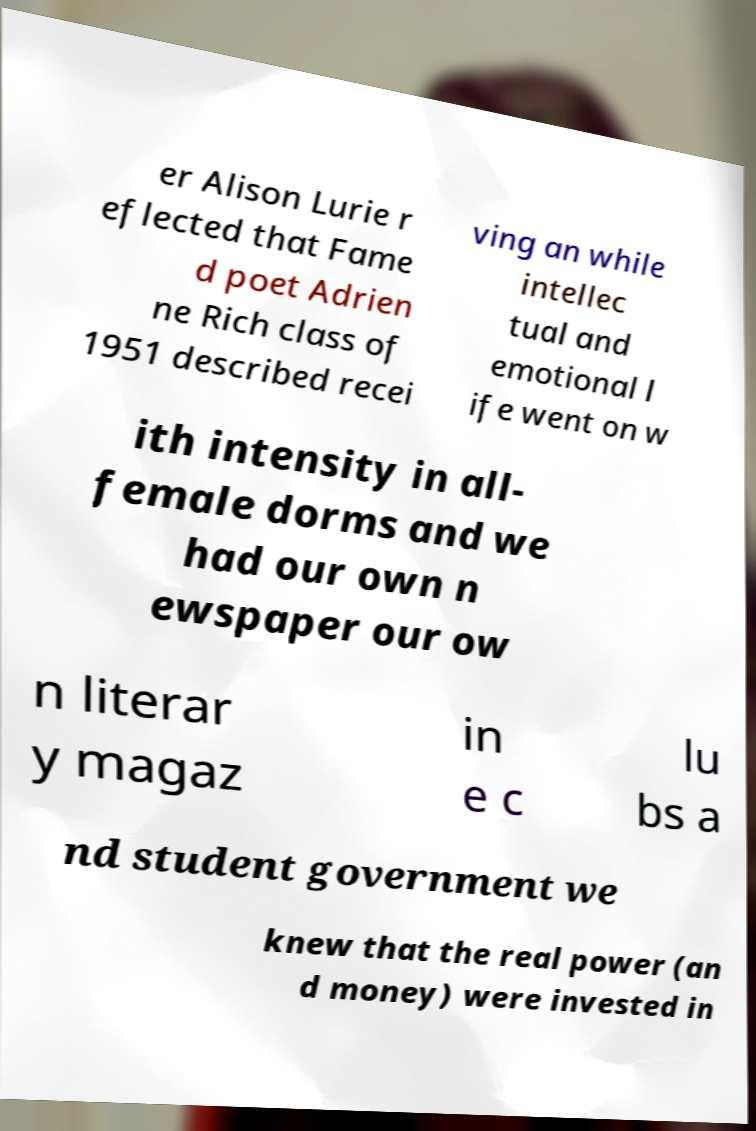Could you extract and type out the text from this image? er Alison Lurie r eflected that Fame d poet Adrien ne Rich class of 1951 described recei ving an while intellec tual and emotional l ife went on w ith intensity in all- female dorms and we had our own n ewspaper our ow n literar y magaz in e c lu bs a nd student government we knew that the real power (an d money) were invested in 